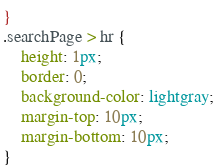<code> <loc_0><loc_0><loc_500><loc_500><_CSS_>}
.searchPage > hr {
    height: 1px;
    border: 0;
    background-color: lightgray;
    margin-top: 10px;
    margin-bottom: 10px;
}
</code> 